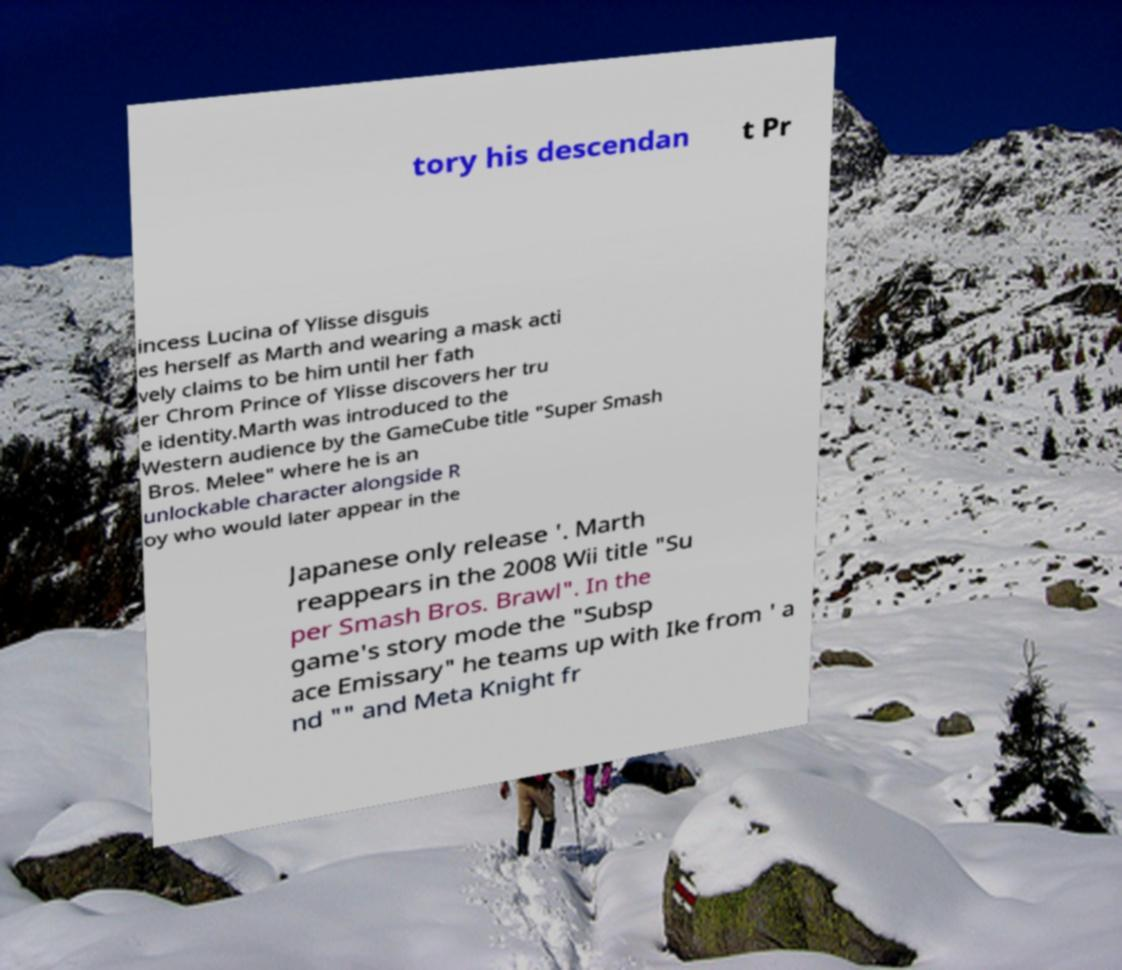Can you accurately transcribe the text from the provided image for me? tory his descendan t Pr incess Lucina of Ylisse disguis es herself as Marth and wearing a mask acti vely claims to be him until her fath er Chrom Prince of Ylisse discovers her tru e identity.Marth was introduced to the Western audience by the GameCube title "Super Smash Bros. Melee" where he is an unlockable character alongside R oy who would later appear in the Japanese only release '. Marth reappears in the 2008 Wii title "Su per Smash Bros. Brawl". In the game's story mode the "Subsp ace Emissary" he teams up with Ike from ' a nd "" and Meta Knight fr 